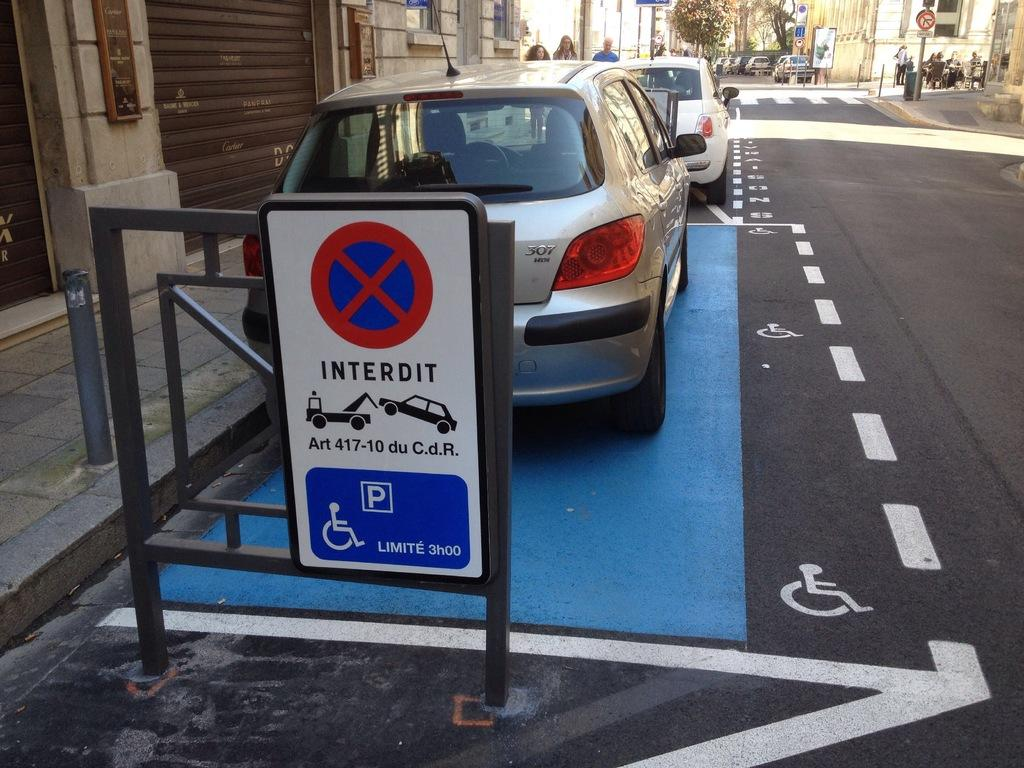What can be seen parked on the side of the road in the image? There are cars parked on the side of the road in the image. What structure is present in the image? There is a stand in the image. What vertical object can be seen in the image? There is a pole in the image. What type of covering is present in the image? There is a shutter in the image. What type of path is visible in the image? There is a footpath in the image. What type of vegetation is present in the image? There are trees in the image. What type of informational display is present in the image? There is a signboard in the image. What type of people can be seen in the image? There are people on the footpath in the image. What type of blood vessels can be seen expanding in the image? There is no reference to blood vessels or expansion in the image; it features cars parked on the side of the road, a stand, a pole, a shutter, a footpath, trees, a signboard, and people on the footpath. What type of spacecraft can be seen in the image? There is no spacecraft present in the image; it features cars parked on the side of the road, a stand, a pole, a shutter, a footpath, trees, a signboard, and people on the footpath. 